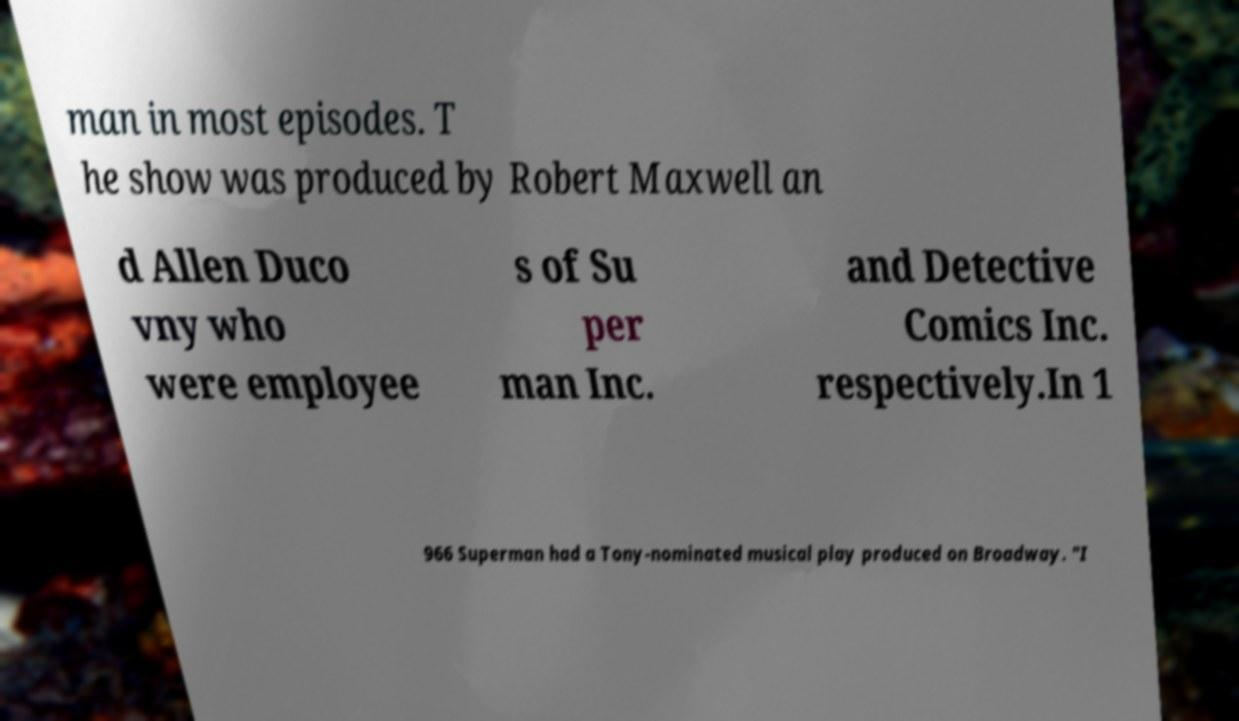Please identify and transcribe the text found in this image. man in most episodes. T he show was produced by Robert Maxwell an d Allen Duco vny who were employee s of Su per man Inc. and Detective Comics Inc. respectively.In 1 966 Superman had a Tony-nominated musical play produced on Broadway. "I 